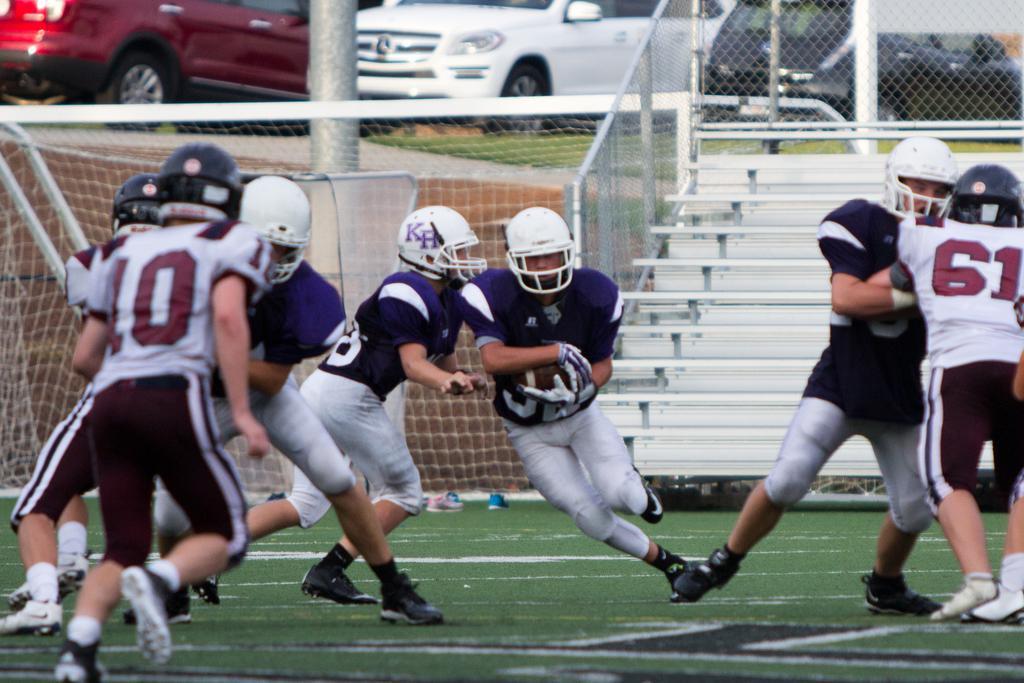Describe this image in one or two sentences. This image is taken outdoors. At the bottom of the image there is a ground with grass on it. In the background a few cars are parked on the ground. There is a mesh and there is a railing. There are a few stairs. There is a goal court. In the middle of the image a few are running on the ground and a man is holding a ball in his hands. 